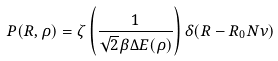<formula> <loc_0><loc_0><loc_500><loc_500>P ( R , \rho ) = \zeta \left ( \frac { 1 } { \sqrt { 2 } \beta \Delta E ( \rho ) } \right ) \delta ( R - R _ { 0 } N \nu )</formula> 